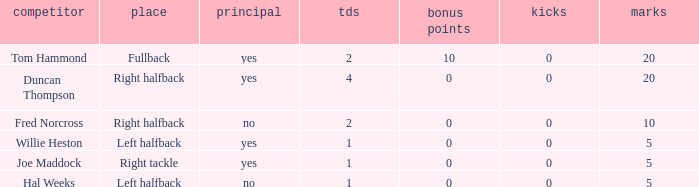What is the lowest number of field goals when the points were less than 5? None. 